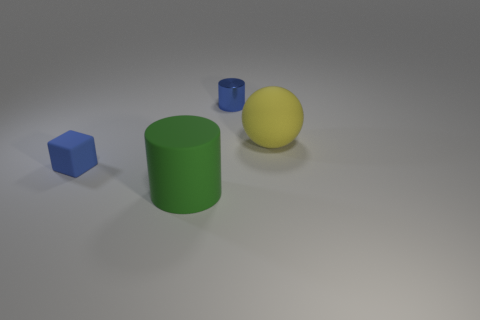Add 1 large yellow matte spheres. How many objects exist? 5 Subtract all balls. How many objects are left? 3 Subtract all blue cylinders. How many cylinders are left? 1 Add 4 large rubber balls. How many large rubber balls are left? 5 Add 4 big yellow spheres. How many big yellow spheres exist? 5 Subtract 0 gray blocks. How many objects are left? 4 Subtract all brown blocks. Subtract all red cylinders. How many blocks are left? 1 Subtract all big matte balls. Subtract all big yellow objects. How many objects are left? 2 